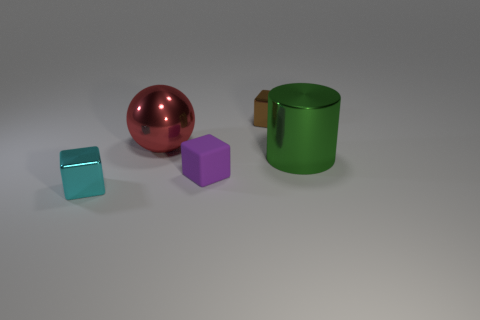Is there anything else that has the same material as the tiny purple object?
Your response must be concise. No. What number of things are either purple matte things or shiny cylinders?
Offer a very short reply. 2. There is a tiny shiny object behind the tiny cyan thing; is it the same shape as the large object on the right side of the brown thing?
Give a very brief answer. No. What number of metal objects are to the left of the matte cube and behind the purple object?
Offer a terse response. 1. How many other objects are there of the same size as the purple matte cube?
Offer a very short reply. 2. What material is the cube that is to the right of the large sphere and in front of the large sphere?
Ensure brevity in your answer.  Rubber. There is a shiny cylinder; does it have the same color as the small block that is left of the large red ball?
Give a very brief answer. No. What is the size of the rubber object that is the same shape as the small cyan metal object?
Make the answer very short. Small. There is a object that is both on the left side of the purple matte thing and behind the cyan metal cube; what shape is it?
Make the answer very short. Sphere. Do the red ball and the metal cube that is behind the tiny cyan metal cube have the same size?
Ensure brevity in your answer.  No. 